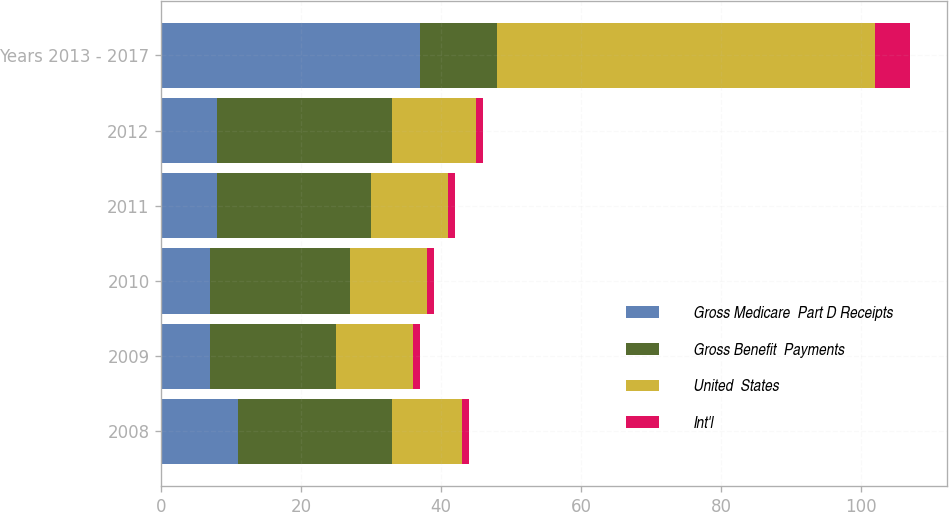Convert chart. <chart><loc_0><loc_0><loc_500><loc_500><stacked_bar_chart><ecel><fcel>2008<fcel>2009<fcel>2010<fcel>2011<fcel>2012<fcel>Years 2013 - 2017<nl><fcel>Gross Medicare  Part D Receipts<fcel>11<fcel>7<fcel>7<fcel>8<fcel>8<fcel>37<nl><fcel>Gross Benefit  Payments<fcel>22<fcel>18<fcel>20<fcel>22<fcel>25<fcel>11<nl><fcel>United  States<fcel>10<fcel>11<fcel>11<fcel>11<fcel>12<fcel>54<nl><fcel>Int'l<fcel>1<fcel>1<fcel>1<fcel>1<fcel>1<fcel>5<nl></chart> 